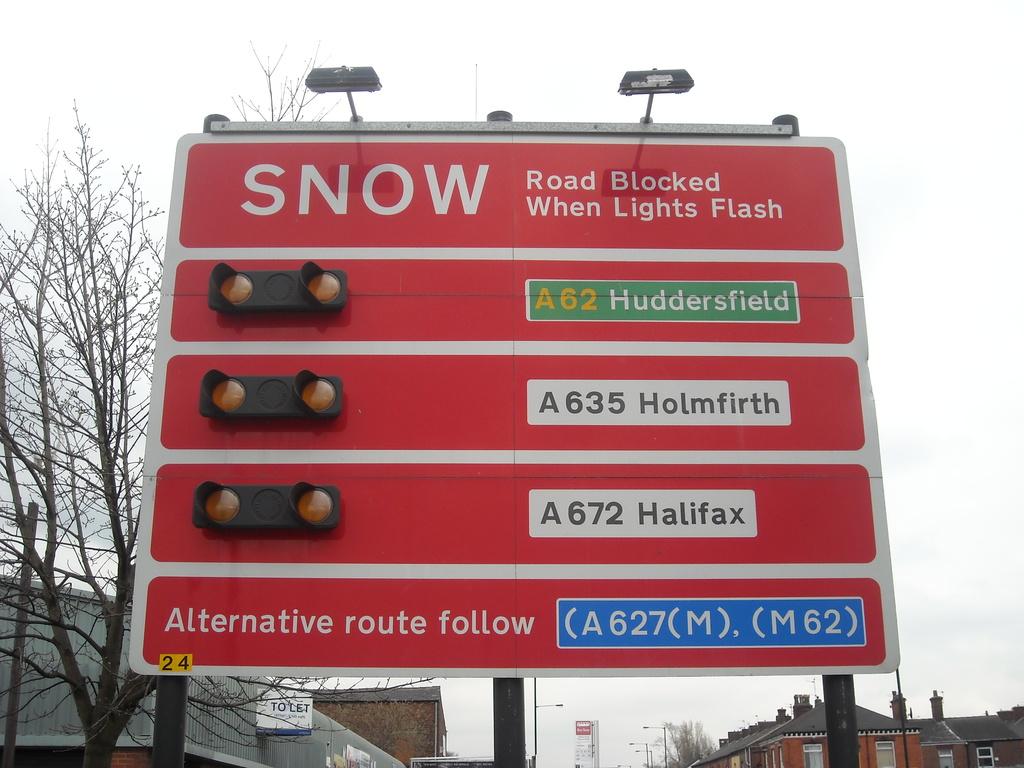Does it snow a lot in this street?
Make the answer very short. Yes. 